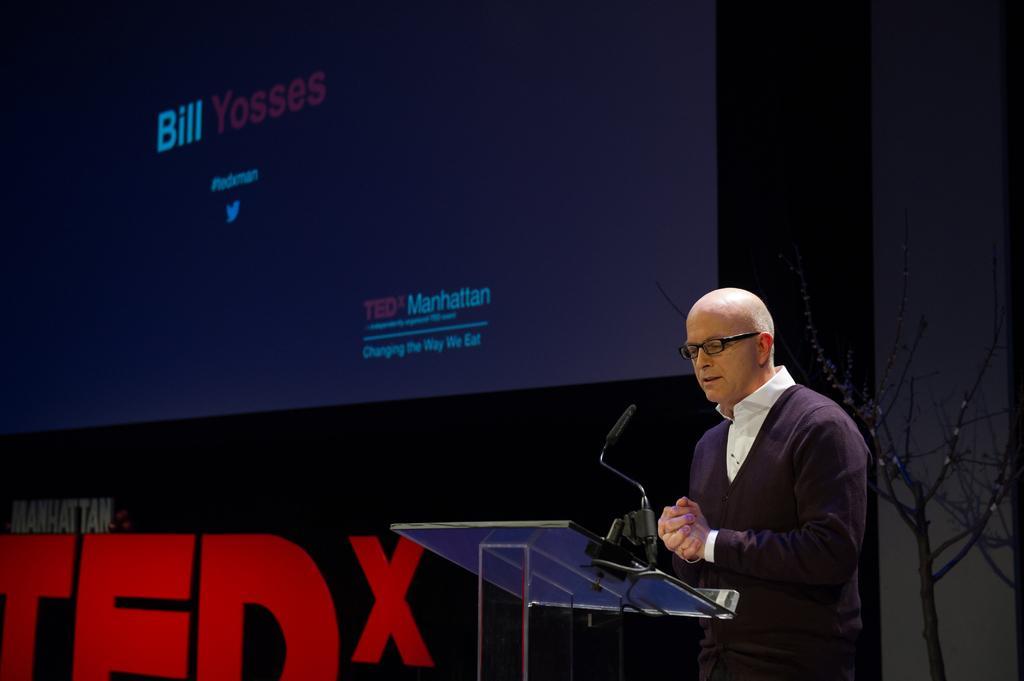Describe this image in one or two sentences. As we can see in the image there is screen, wall, dry plant, mic and a person wearing black color jacket. 